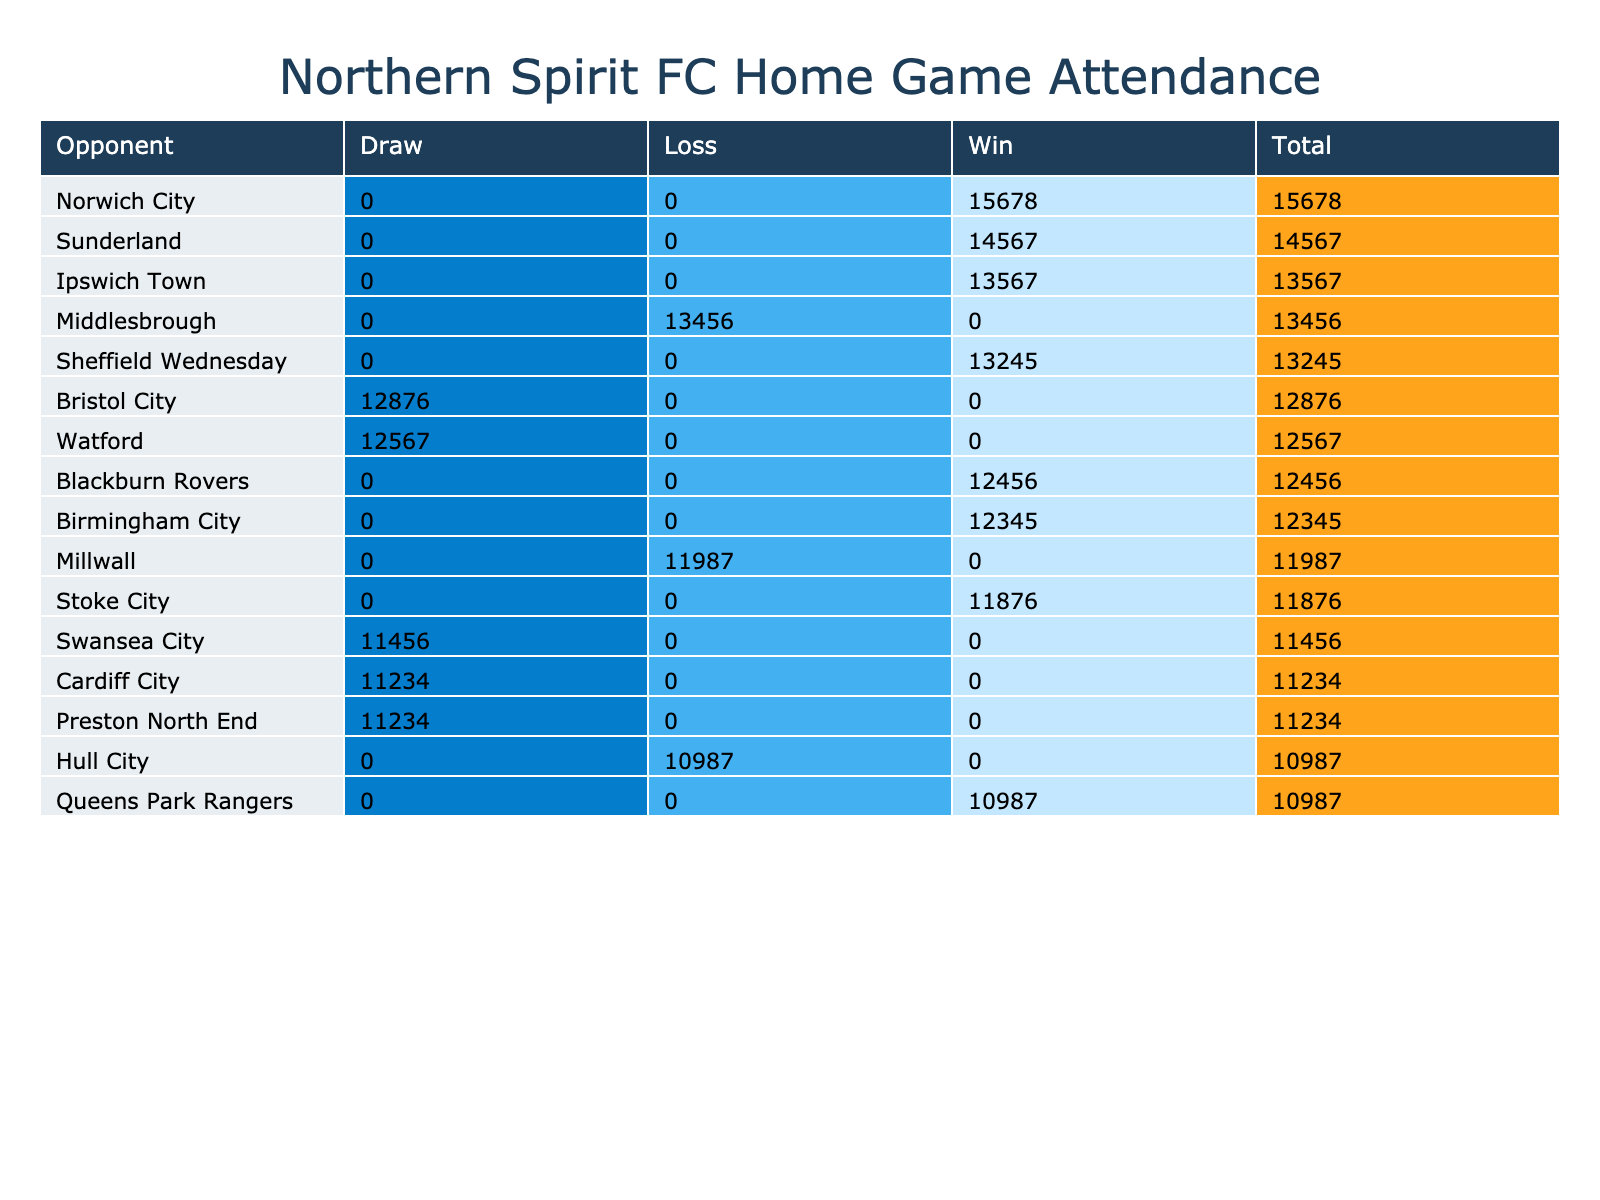What is the total attendance for the home game against Sunderland? The table shows that the attendance for the game against Sunderland is listed as 14567.
Answer: 14567 Which opponent had the highest total attendance? By looking at the Total column in the table, Sunderland has the highest attendance with a total of 14567.
Answer: Sunderland How many total wins did Northern Spirit FC achieve at home? To find the total wins, I count the number of times "Win" appears as a match result. The wins occurred against Blackburn Rovers, Sheffield Wednesday, Stoke City, Sunderland, Norwich City, Birmingham City, Ipswich Town—totaling 7 wins.
Answer: 7 What was the average attendance for matches that ended in a draw? I first filter for matches that ended in a draw (Preston North End, Watford, Cardiff City, Swansea City, and Bristol City) and find their attendances: 11234, 12567, 11234, 11456, and 12876. Then I calculate the average: (11234 + 12567 + 11234 + 11456 + 12876) / 5 = 11813.
Answer: 11813 Did Northern Spirit FC win more matches than they lost at home? By comparing the count of matches with "Win" and "Loss" in the Match Result column, there are 7 wins and 3 losses. Since 7 is greater than 3, the answer is yes.
Answer: Yes Which opponent had the lowest attendance in a match that Northern Spirit FC won? From the table, the matches that ended in a win were against Blackburn Rovers, Sheffield Wednesday, Stoke City, Sunderland, Norwich City, Birmingham City, and Ipswich Town. Their respective attendance values are: 12456, 13245, 11876, 14567, 15678, 12345, and 13567. The lowest attendance among these is 11876 against Stoke City.
Answer: Stoke City What is the difference in total attendance between the matches against Cardiff City and Ipswich Town? We look for the total attendance for Cardiff City (11234) and Ipswich Town (13567). The difference is calculated as 13567 - 11234 = 2333.
Answer: 2333 How many total tickets were sold for the home match against Millwall? The table shows the attendance for Millwall as 11987. Since each attendee represents a sold ticket, the total number of tickets sold is equal to the attendance, which is 11987.
Answer: 11987 